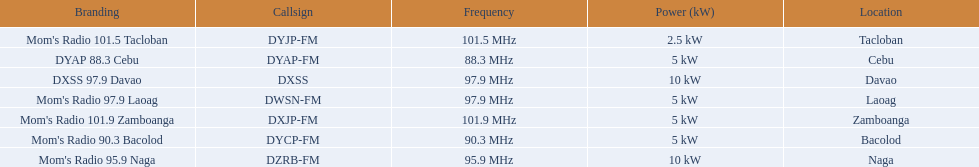What is the quantity of these stations airing at a frequency of over 100 mhz? 2. 